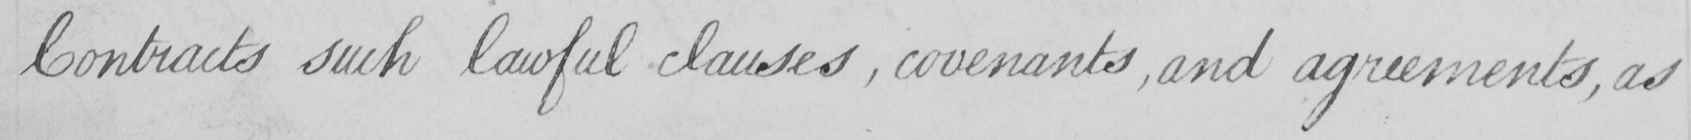Can you read and transcribe this handwriting? Contracts such lawful clauses , covenants , and agreements , as 